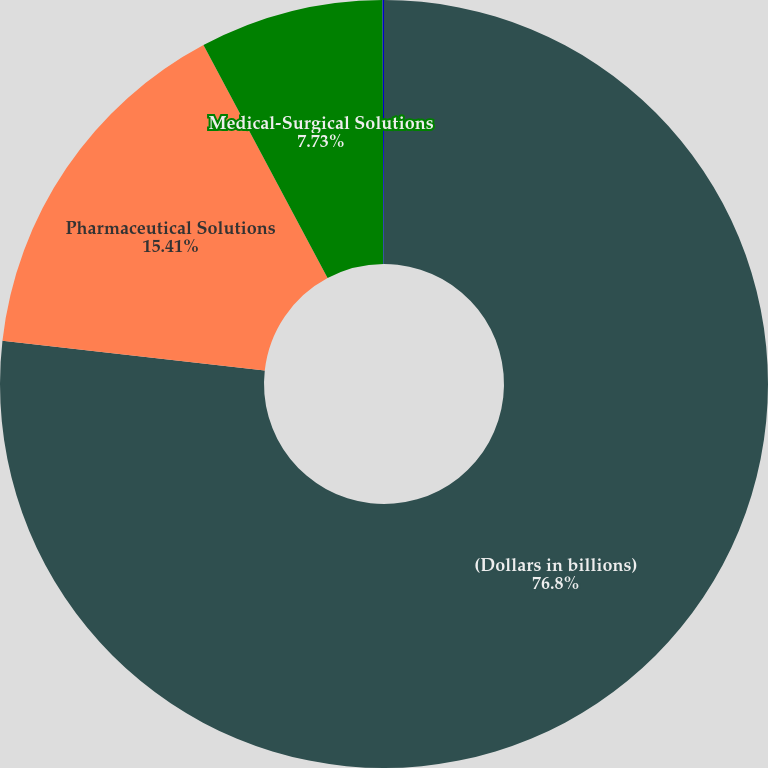<chart> <loc_0><loc_0><loc_500><loc_500><pie_chart><fcel>(Dollars in billions)<fcel>Pharmaceutical Solutions<fcel>Medical-Surgical Solutions<fcel>Provider Technologies<nl><fcel>76.8%<fcel>15.41%<fcel>7.73%<fcel>0.06%<nl></chart> 